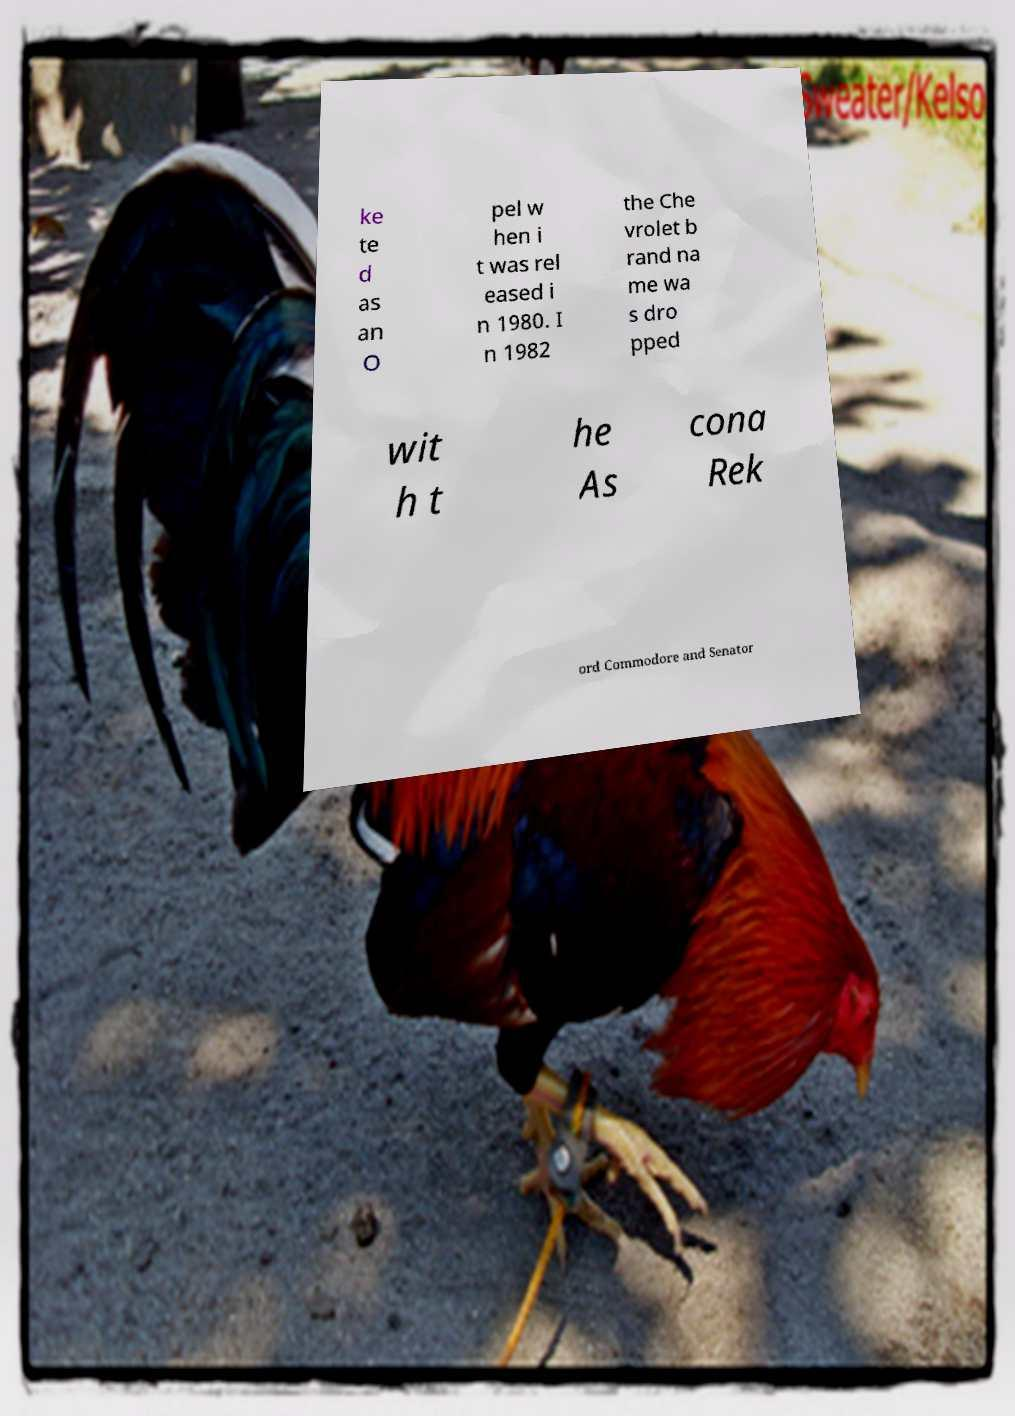I need the written content from this picture converted into text. Can you do that? ke te d as an O pel w hen i t was rel eased i n 1980. I n 1982 the Che vrolet b rand na me wa s dro pped wit h t he As cona Rek ord Commodore and Senator 